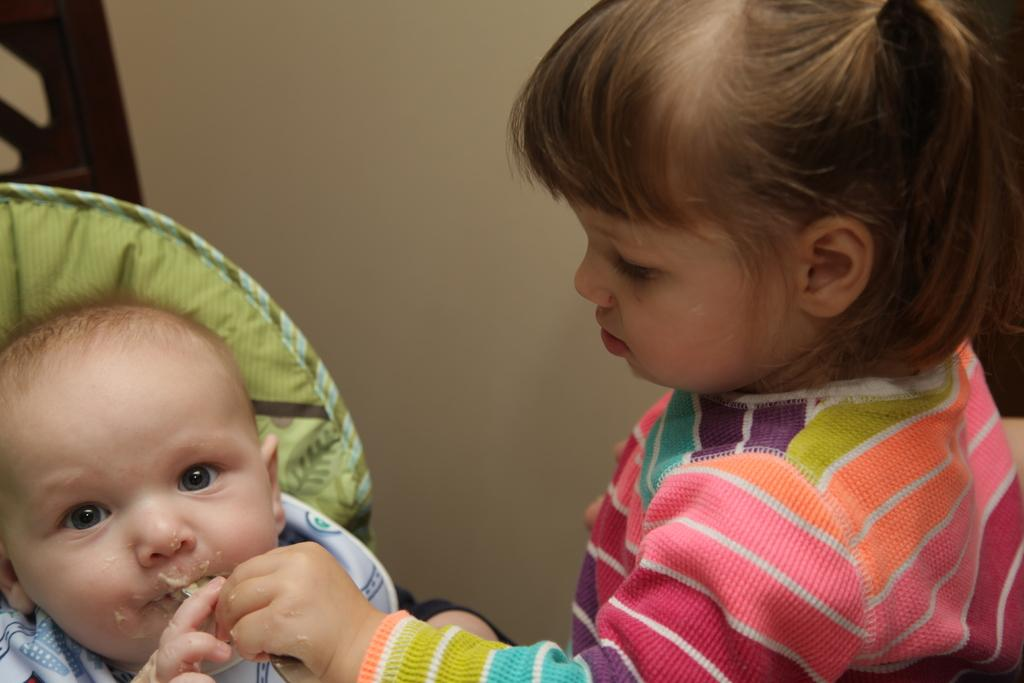What is happening in the image? There is a child in the image who is feeding a baby. What can be seen in the background of the image? There is a wall in the background of the image. What type of ship can be seen in the middle of the image? There is no ship present in the image; it features a child feeding a baby with a wall in the background. 